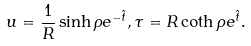Convert formula to latex. <formula><loc_0><loc_0><loc_500><loc_500>u = \frac { 1 } { R } \sinh \rho e ^ { - \hat { t } } , \tau = R \coth \rho e ^ { \hat { t } } .</formula> 